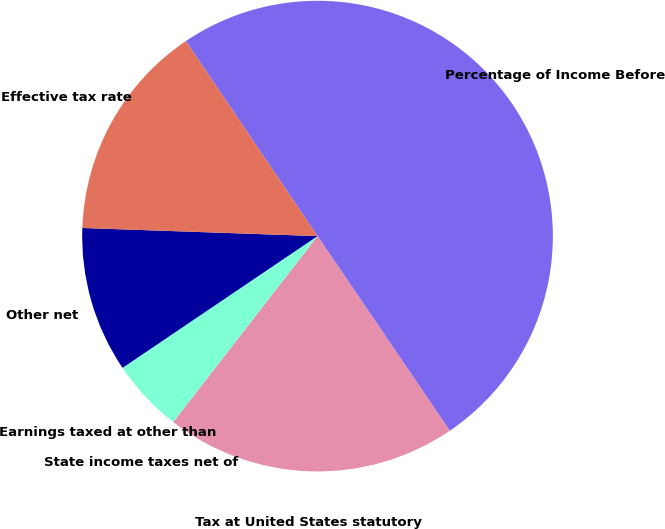Convert chart. <chart><loc_0><loc_0><loc_500><loc_500><pie_chart><fcel>Percentage of Income Before<fcel>Tax at United States statutory<fcel>State income taxes net of<fcel>Earnings taxed at other than<fcel>Other net<fcel>Effective tax rate<nl><fcel>49.95%<fcel>20.0%<fcel>0.02%<fcel>5.02%<fcel>10.01%<fcel>15.0%<nl></chart> 